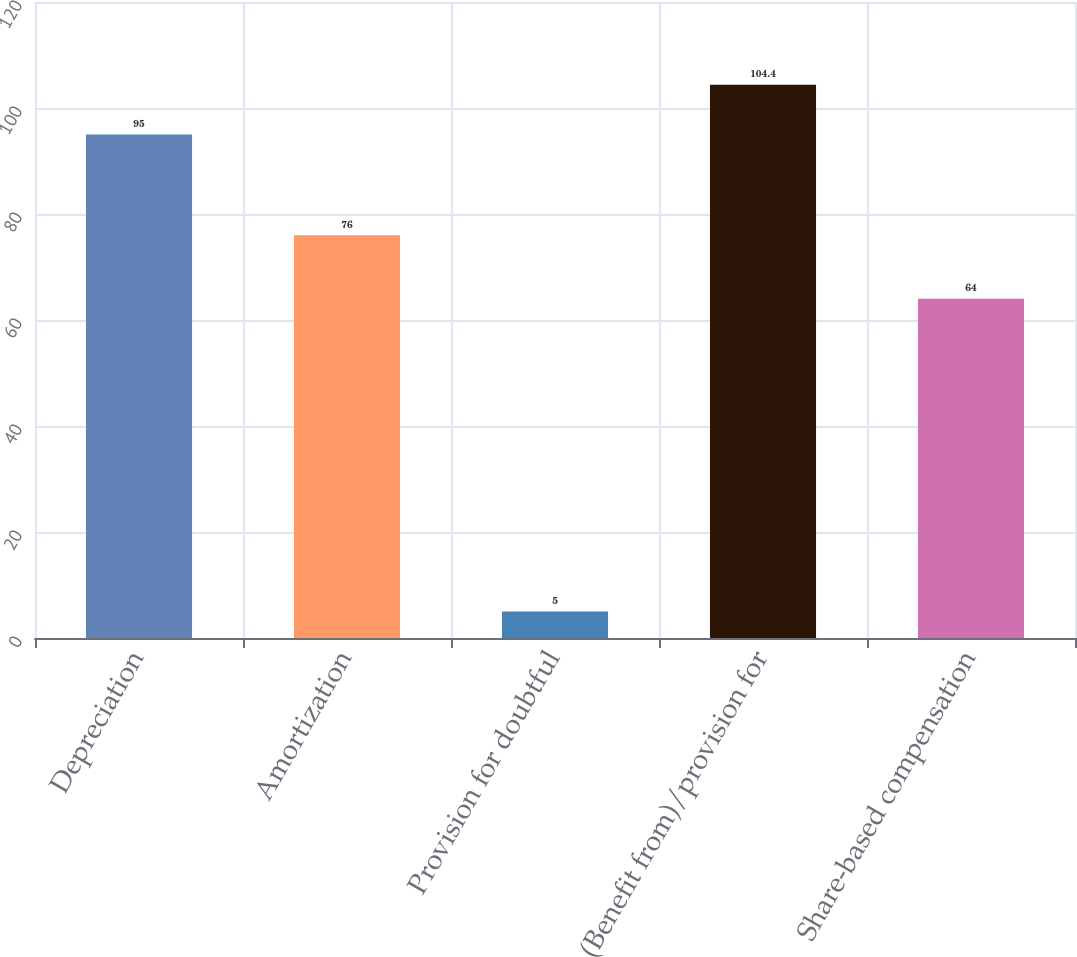Convert chart. <chart><loc_0><loc_0><loc_500><loc_500><bar_chart><fcel>Depreciation<fcel>Amortization<fcel>Provision for doubtful<fcel>(Benefit from)/provision for<fcel>Share-based compensation<nl><fcel>95<fcel>76<fcel>5<fcel>104.4<fcel>64<nl></chart> 